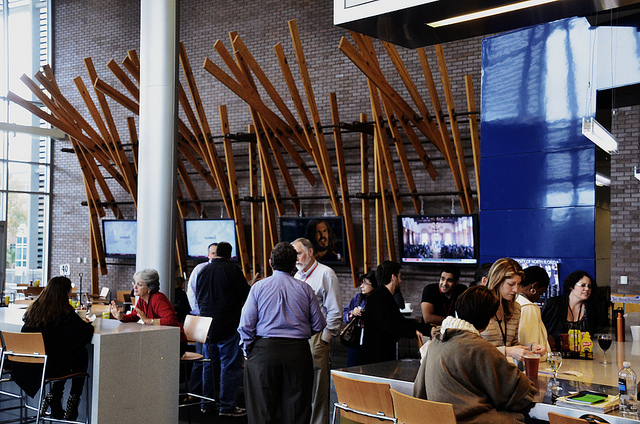<image>What does the name say on the blocks of wood? There is no visible name on the blocks of wood. What does the name say on the blocks of wood? The name on the blocks of wood is not visible. 